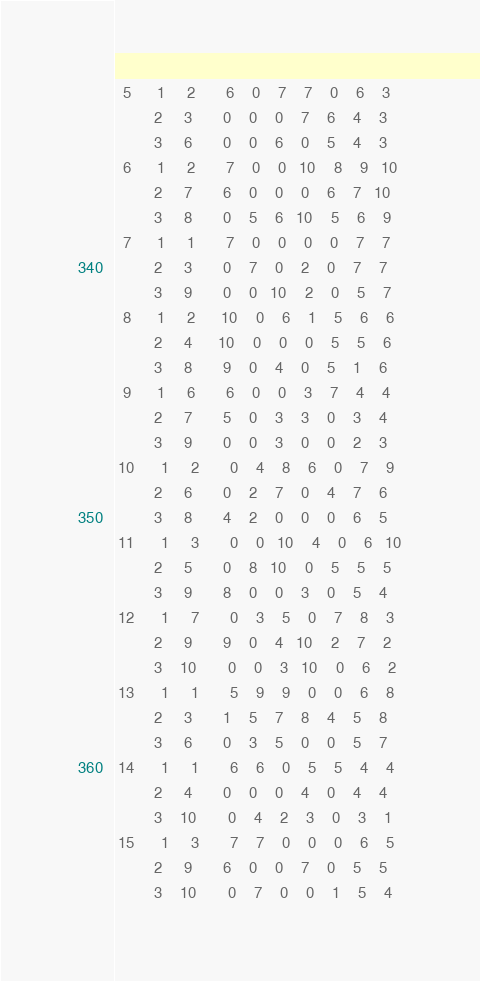<code> <loc_0><loc_0><loc_500><loc_500><_ObjectiveC_>  5      1     2       6    0    7    7    0    6    3
         2     3       0    0    0    7    6    4    3
         3     6       0    0    6    0    5    4    3
  6      1     2       7    0    0   10    8    9   10
         2     7       6    0    0    0    6    7   10
         3     8       0    5    6   10    5    6    9
  7      1     1       7    0    0    0    0    7    7
         2     3       0    7    0    2    0    7    7
         3     9       0    0   10    2    0    5    7
  8      1     2      10    0    6    1    5    6    6
         2     4      10    0    0    0    5    5    6
         3     8       9    0    4    0    5    1    6
  9      1     6       6    0    0    3    7    4    4
         2     7       5    0    3    3    0    3    4
         3     9       0    0    3    0    0    2    3
 10      1     2       0    4    8    6    0    7    9
         2     6       0    2    7    0    4    7    6
         3     8       4    2    0    0    0    6    5
 11      1     3       0    0   10    4    0    6   10
         2     5       0    8   10    0    5    5    5
         3     9       8    0    0    3    0    5    4
 12      1     7       0    3    5    0    7    8    3
         2     9       9    0    4   10    2    7    2
         3    10       0    0    3   10    0    6    2
 13      1     1       5    9    9    0    0    6    8
         2     3       1    5    7    8    4    5    8
         3     6       0    3    5    0    0    5    7
 14      1     1       6    6    0    5    5    4    4
         2     4       0    0    0    4    0    4    4
         3    10       0    4    2    3    0    3    1
 15      1     3       7    7    0    0    0    6    5
         2     9       6    0    0    7    0    5    5
         3    10       0    7    0    0    1    5    4</code> 